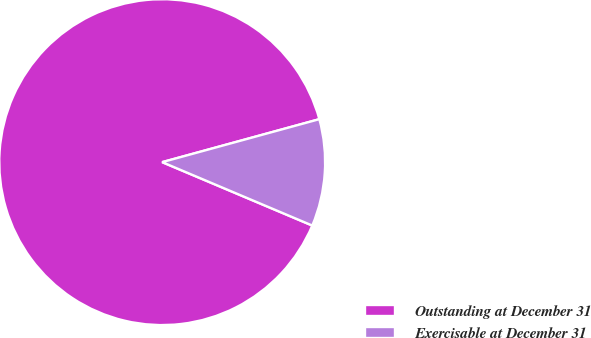<chart> <loc_0><loc_0><loc_500><loc_500><pie_chart><fcel>Outstanding at December 31<fcel>Exercisable at December 31<nl><fcel>89.39%<fcel>10.61%<nl></chart> 